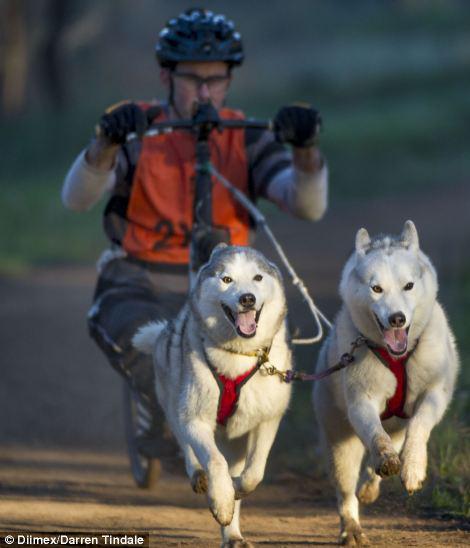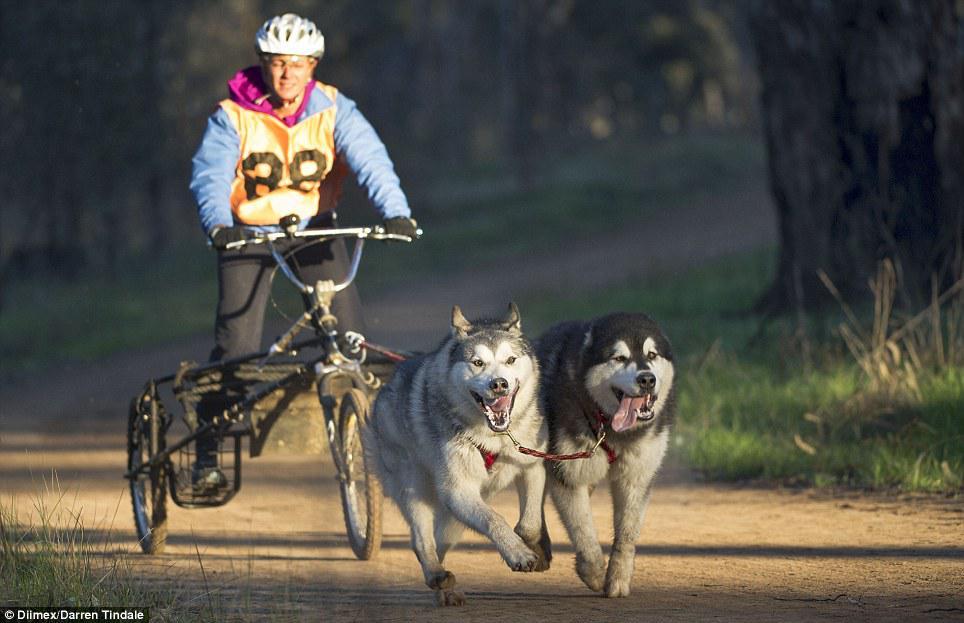The first image is the image on the left, the second image is the image on the right. Examine the images to the left and right. Is the description "The sled rider in the image on the left is wearing a white vest with a number." accurate? Answer yes or no. No. The first image is the image on the left, the second image is the image on the right. Assess this claim about the two images: "Right image shows a team of dogs moving over snowy ground toward the camera.". Correct or not? Answer yes or no. No. 